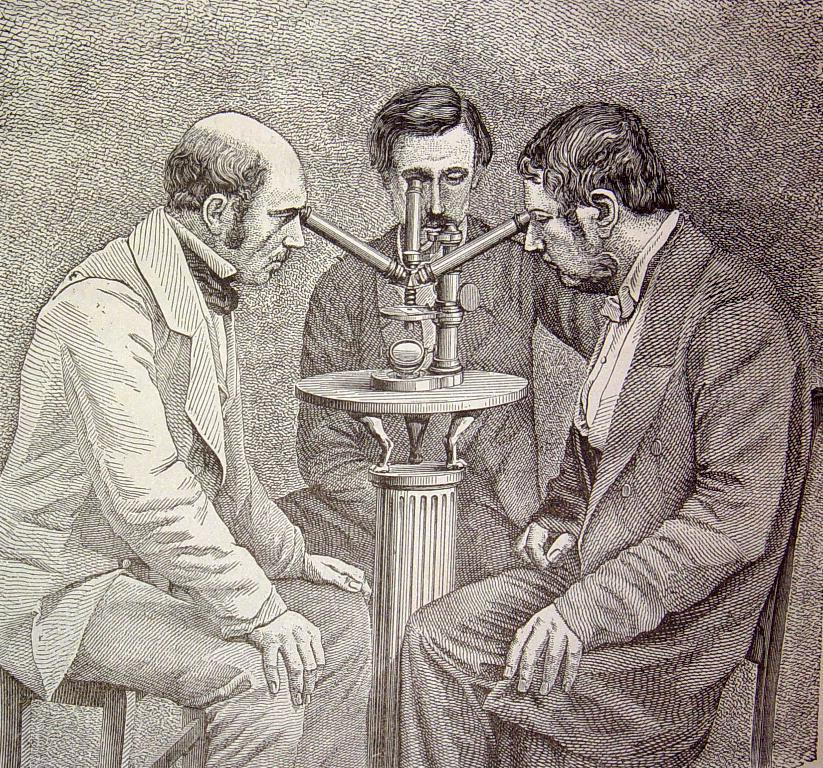What are the people in the image doing? The people in the image are sitting on chairs. Can you describe the object in the image? Unfortunately, there is not enough information provided to describe the object in the image. What type of disease is being discussed by the people in the image? There is no indication in the image that the people are discussing any disease. 